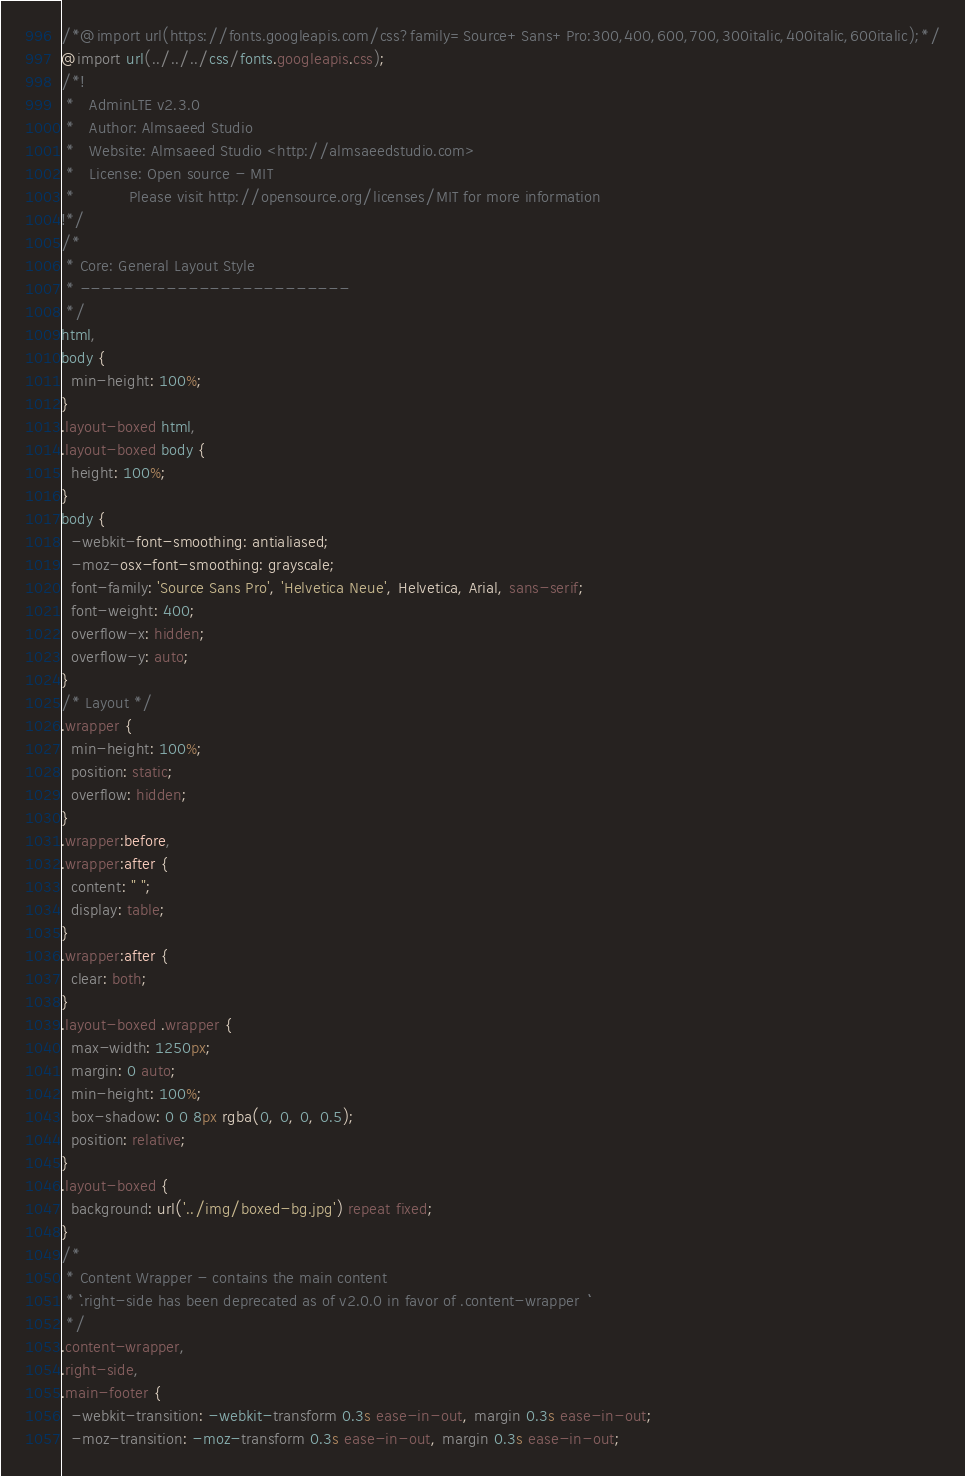Convert code to text. <code><loc_0><loc_0><loc_500><loc_500><_CSS_>/*@import url(https://fonts.googleapis.com/css?family=Source+Sans+Pro:300,400,600,700,300italic,400italic,600italic);*/
@import url(../../../css/fonts.googleapis.css);
/*!
 *   AdminLTE v2.3.0
 *   Author: Almsaeed Studio
 *	 Website: Almsaeed Studio <http://almsaeedstudio.com>
 *   License: Open source - MIT
 *           Please visit http://opensource.org/licenses/MIT for more information
!*/
/*
 * Core: General Layout Style
 * -------------------------
 */
html,
body {
  min-height: 100%;
}
.layout-boxed html,
.layout-boxed body {
  height: 100%;
}
body {
  -webkit-font-smoothing: antialiased;
  -moz-osx-font-smoothing: grayscale;
  font-family: 'Source Sans Pro', 'Helvetica Neue', Helvetica, Arial, sans-serif;
  font-weight: 400;
  overflow-x: hidden;
  overflow-y: auto;
}
/* Layout */
.wrapper {
  min-height: 100%;
  position: static;
  overflow: hidden;
}
.wrapper:before,
.wrapper:after {
  content: " ";
  display: table;
}
.wrapper:after {
  clear: both;
}
.layout-boxed .wrapper {
  max-width: 1250px;
  margin: 0 auto;
  min-height: 100%;
  box-shadow: 0 0 8px rgba(0, 0, 0, 0.5);
  position: relative;
}
.layout-boxed {
  background: url('../img/boxed-bg.jpg') repeat fixed;
}
/*
 * Content Wrapper - contains the main content
 * ```.right-side has been deprecated as of v2.0.0 in favor of .content-wrapper  ```
 */
.content-wrapper,
.right-side,
.main-footer {
  -webkit-transition: -webkit-transform 0.3s ease-in-out, margin 0.3s ease-in-out;
  -moz-transition: -moz-transform 0.3s ease-in-out, margin 0.3s ease-in-out;</code> 